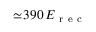<formula> <loc_0><loc_0><loc_500><loc_500>\simeq \, 3 9 0 \, E _ { r e c }</formula> 